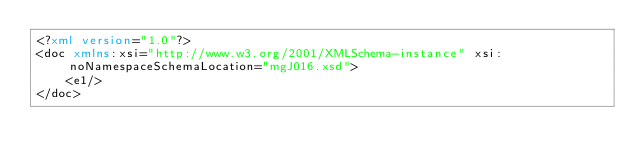<code> <loc_0><loc_0><loc_500><loc_500><_XML_><?xml version="1.0"?>
<doc xmlns:xsi="http://www.w3.org/2001/XMLSchema-instance" xsi:noNamespaceSchemaLocation="mgJ016.xsd">
	<e1/>
</doc>
</code> 